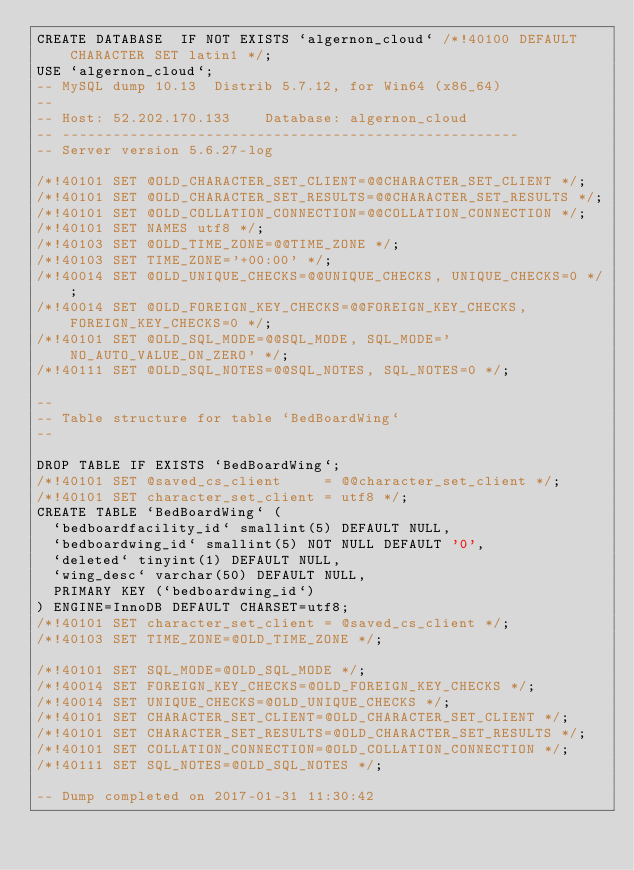<code> <loc_0><loc_0><loc_500><loc_500><_SQL_>CREATE DATABASE  IF NOT EXISTS `algernon_cloud` /*!40100 DEFAULT CHARACTER SET latin1 */;
USE `algernon_cloud`;
-- MySQL dump 10.13  Distrib 5.7.12, for Win64 (x86_64)
--
-- Host: 52.202.170.133    Database: algernon_cloud
-- ------------------------------------------------------
-- Server version	5.6.27-log

/*!40101 SET @OLD_CHARACTER_SET_CLIENT=@@CHARACTER_SET_CLIENT */;
/*!40101 SET @OLD_CHARACTER_SET_RESULTS=@@CHARACTER_SET_RESULTS */;
/*!40101 SET @OLD_COLLATION_CONNECTION=@@COLLATION_CONNECTION */;
/*!40101 SET NAMES utf8 */;
/*!40103 SET @OLD_TIME_ZONE=@@TIME_ZONE */;
/*!40103 SET TIME_ZONE='+00:00' */;
/*!40014 SET @OLD_UNIQUE_CHECKS=@@UNIQUE_CHECKS, UNIQUE_CHECKS=0 */;
/*!40014 SET @OLD_FOREIGN_KEY_CHECKS=@@FOREIGN_KEY_CHECKS, FOREIGN_KEY_CHECKS=0 */;
/*!40101 SET @OLD_SQL_MODE=@@SQL_MODE, SQL_MODE='NO_AUTO_VALUE_ON_ZERO' */;
/*!40111 SET @OLD_SQL_NOTES=@@SQL_NOTES, SQL_NOTES=0 */;

--
-- Table structure for table `BedBoardWing`
--

DROP TABLE IF EXISTS `BedBoardWing`;
/*!40101 SET @saved_cs_client     = @@character_set_client */;
/*!40101 SET character_set_client = utf8 */;
CREATE TABLE `BedBoardWing` (
  `bedboardfacility_id` smallint(5) DEFAULT NULL,
  `bedboardwing_id` smallint(5) NOT NULL DEFAULT '0',
  `deleted` tinyint(1) DEFAULT NULL,
  `wing_desc` varchar(50) DEFAULT NULL,
  PRIMARY KEY (`bedboardwing_id`)
) ENGINE=InnoDB DEFAULT CHARSET=utf8;
/*!40101 SET character_set_client = @saved_cs_client */;
/*!40103 SET TIME_ZONE=@OLD_TIME_ZONE */;

/*!40101 SET SQL_MODE=@OLD_SQL_MODE */;
/*!40014 SET FOREIGN_KEY_CHECKS=@OLD_FOREIGN_KEY_CHECKS */;
/*!40014 SET UNIQUE_CHECKS=@OLD_UNIQUE_CHECKS */;
/*!40101 SET CHARACTER_SET_CLIENT=@OLD_CHARACTER_SET_CLIENT */;
/*!40101 SET CHARACTER_SET_RESULTS=@OLD_CHARACTER_SET_RESULTS */;
/*!40101 SET COLLATION_CONNECTION=@OLD_COLLATION_CONNECTION */;
/*!40111 SET SQL_NOTES=@OLD_SQL_NOTES */;

-- Dump completed on 2017-01-31 11:30:42
</code> 